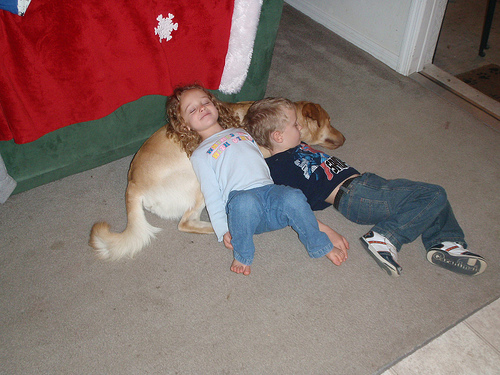<image>
Can you confirm if the dog is on the girl? No. The dog is not positioned on the girl. They may be near each other, but the dog is not supported by or resting on top of the girl. Is the dog to the left of the boy? No. The dog is not to the left of the boy. From this viewpoint, they have a different horizontal relationship. Where is the girl in relation to the dog? Is it above the dog? Yes. The girl is positioned above the dog in the vertical space, higher up in the scene. 